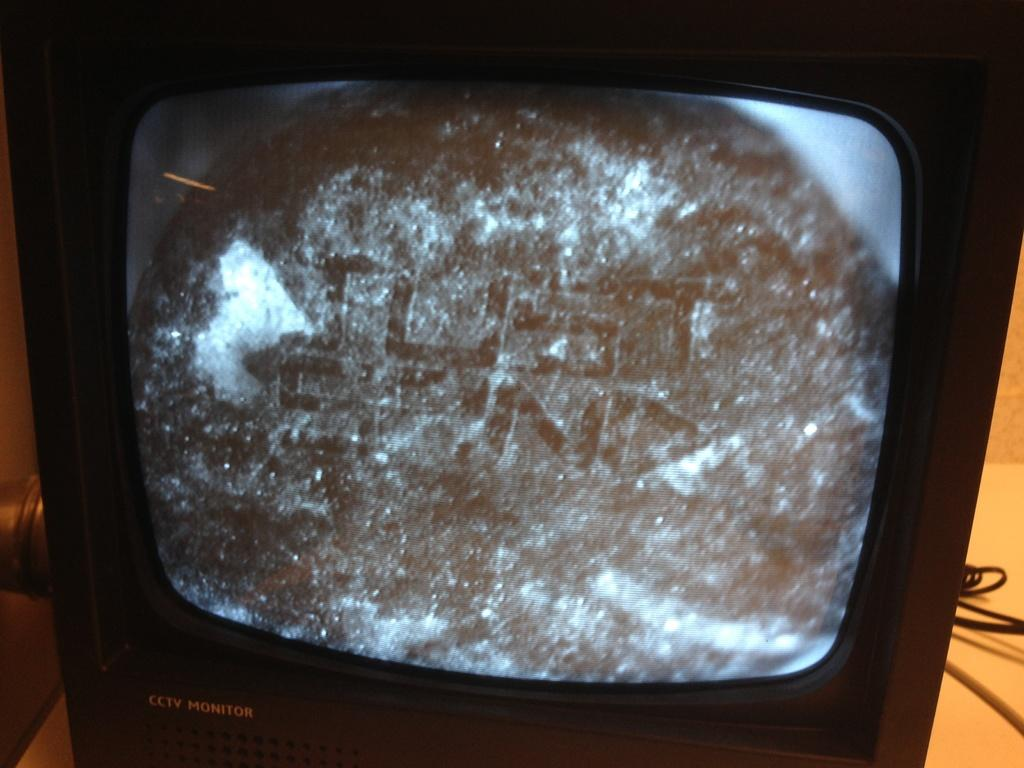<image>
Present a compact description of the photo's key features. A CCTV monitor playing a video and the screenshot says "Just Send". 